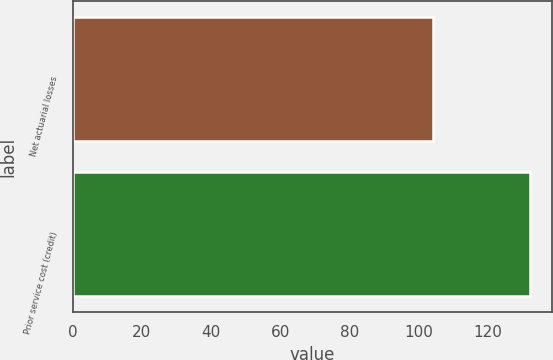Convert chart. <chart><loc_0><loc_0><loc_500><loc_500><bar_chart><fcel>Net actuarial losses<fcel>Prior service cost (credit)<nl><fcel>104<fcel>132<nl></chart> 